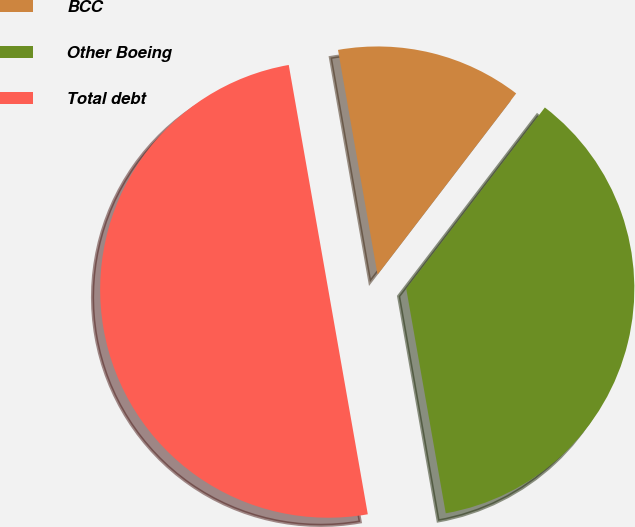Convert chart. <chart><loc_0><loc_0><loc_500><loc_500><pie_chart><fcel>BCC<fcel>Other Boeing<fcel>Total debt<nl><fcel>13.17%<fcel>36.83%<fcel>50.0%<nl></chart> 